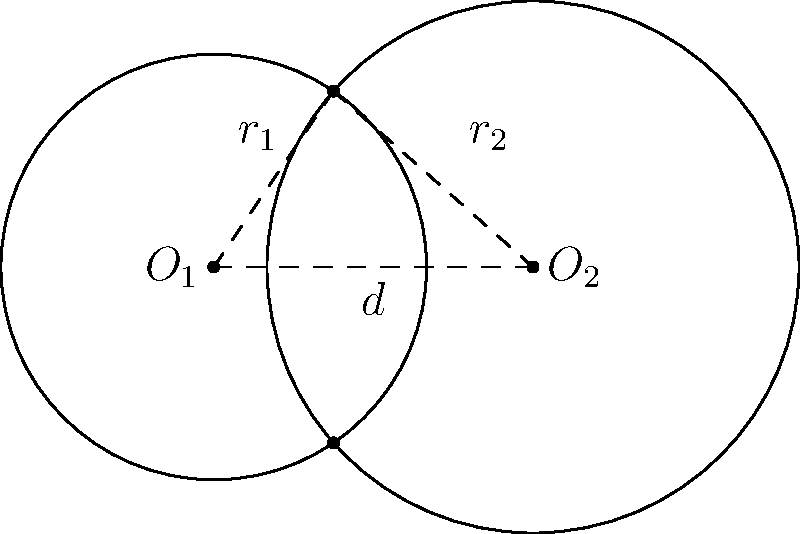As a data scientist, you're analyzing the overlap of two circular datasets. The centers of these datasets are represented by two circles with radii $r_1 = 2$ units and $r_2 = 2.5$ units, respectively. The distance between their centers is $d = 3$ units. Calculate the area of the overlapping region (shaded area) where these datasets intersect. Round your answer to two decimal places. To solve this problem, we'll follow these steps:

1) First, we need to calculate the angle $\theta$ at the center of each circle that forms the sector of overlap. We can do this using the law of cosines:

   For circle 1: $\cos(\theta_1) = \frac{r_1^2 + d^2 - r_2^2}{2r_1d}$
   For circle 2: $\cos(\theta_2) = \frac{r_2^2 + d^2 - r_1^2}{2r_2d}$

2) Calculate $\theta_1$:
   $\cos(\theta_1) = \frac{2^2 + 3^2 - 2.5^2}{2 \cdot 2 \cdot 3} = 0.3125$
   $\theta_1 = \arccos(0.3125) = 1.2490$ radians

3) Calculate $\theta_2$:
   $\cos(\theta_2) = \frac{2.5^2 + 3^2 - 2^2}{2 \cdot 2.5 \cdot 3} = 0.5833$
   $\theta_2 = \arccos(0.5833) = 0.9553$ radians

4) The area of overlap is the sum of the areas of the two circular sectors minus the area of the rhombus formed by the intersection points and the centers of the circles:

   Area = $r_1^2 \theta_1 + r_2^2 \theta_2 - 2 \cdot \frac{1}{2}r_1r_2\sin(\theta_1)$

5) Substitute the values:
   Area = $2^2 \cdot 1.2490 + 2.5^2 \cdot 0.9553 - 2 \cdot 2 \cdot 2.5 \cdot \sin(1.2490)$
        = $4.9960 + 5.9706 - 8.1752$
        = $2.7914$ square units

6) Rounding to two decimal places: $2.79$ square units

This approach demonstrates the importance of understanding the underlying geometry and applying mathematical concepts to solve data-related problems.
Answer: $2.79$ square units 